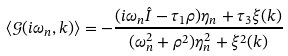<formula> <loc_0><loc_0><loc_500><loc_500>\langle \mathcal { G } ( i \omega _ { n } , k ) \rangle = - \frac { ( i \omega _ { n } \hat { I } - \tau _ { 1 } \rho ) \eta _ { n } + \tau _ { 3 } \xi ( k ) } { ( \omega _ { n } ^ { 2 } + \rho ^ { 2 } ) \eta _ { n } ^ { 2 } + \xi ^ { 2 } ( k ) }</formula> 